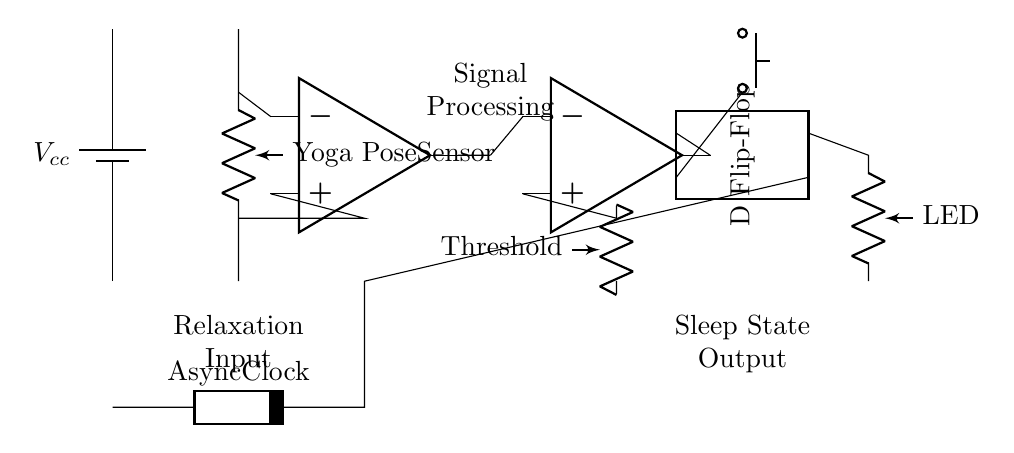What is the power supply used in this circuit? The power supply in this circuit is designated as "V cc," which indicates it is a voltage source. This can be identified from the circuit diagram where a battery symbol is connected to the main part of the circuit.
Answer: V cc What type of sensor is incorporated in the circuit? The circuit includes a "Yoga Pose Sensor." This is indicated by the label next to the first component in the circuit diagram, which connects to the amplifier.
Answer: Yoga Pose Sensor What is the primary purpose of the amplifier in the circuit? The amplifier's role in the circuit is to enhance the signal from the Yoga Pose Sensor before sending it to the comparator. This can be understood by following the electrical flow from the sensor to the amplifier and noting its position in the signal path.
Answer: Signal enhancement What type of flip-flop is used in this circuit? The circuit uses a D Flip-Flop, as specifically noted by the symbol and label for the component. This distinguishes it from other types of flip-flops, confirming its function in memory storage.
Answer: D Flip-Flop How does the reset mechanism operate in this circuit? The reset mechanism is implemented using a push button that connects to the flip-flop's second pin, indicating that pressing this button sends a signal to reset the flip-flop, affecting its output state. This is evident from the direct connection illustrated in the circuit diagram.
Answer: Push button What is the role of the comparator in this circuit? The comparator's function is to compare the output from the amplifier against a threshold voltage. This is evident by the connection of two inputs: one from the amplifier's output and the other coming from a threshold resistor network, which determines whether the output state of the flip-flop should change.
Answer: Signal comparison 